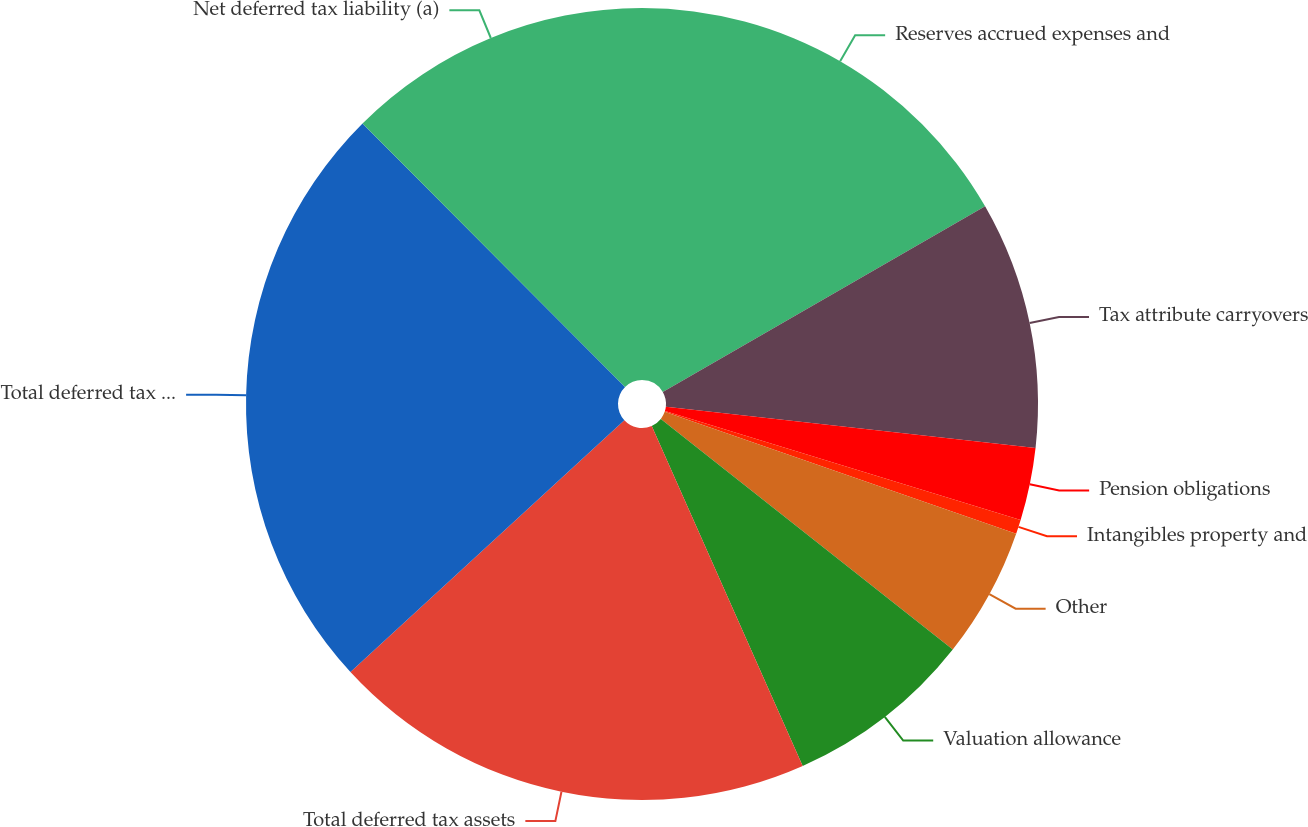Convert chart. <chart><loc_0><loc_0><loc_500><loc_500><pie_chart><fcel>Reserves accrued expenses and<fcel>Tax attribute carryovers<fcel>Pension obligations<fcel>Intangibles property and<fcel>Other<fcel>Valuation allowance<fcel>Total deferred tax assets<fcel>Total deferred tax liabilities<fcel>Net deferred tax liability (a)<nl><fcel>16.68%<fcel>10.09%<fcel>2.96%<fcel>0.58%<fcel>5.33%<fcel>7.71%<fcel>19.82%<fcel>24.36%<fcel>12.47%<nl></chart> 